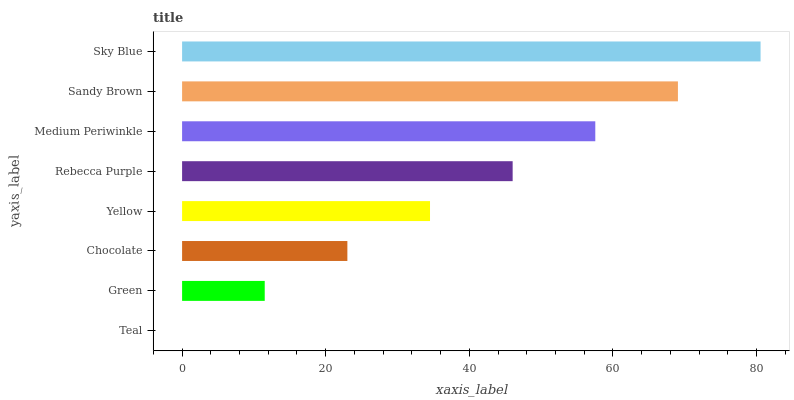Is Teal the minimum?
Answer yes or no. Yes. Is Sky Blue the maximum?
Answer yes or no. Yes. Is Green the minimum?
Answer yes or no. No. Is Green the maximum?
Answer yes or no. No. Is Green greater than Teal?
Answer yes or no. Yes. Is Teal less than Green?
Answer yes or no. Yes. Is Teal greater than Green?
Answer yes or no. No. Is Green less than Teal?
Answer yes or no. No. Is Rebecca Purple the high median?
Answer yes or no. Yes. Is Yellow the low median?
Answer yes or no. Yes. Is Teal the high median?
Answer yes or no. No. Is Rebecca Purple the low median?
Answer yes or no. No. 